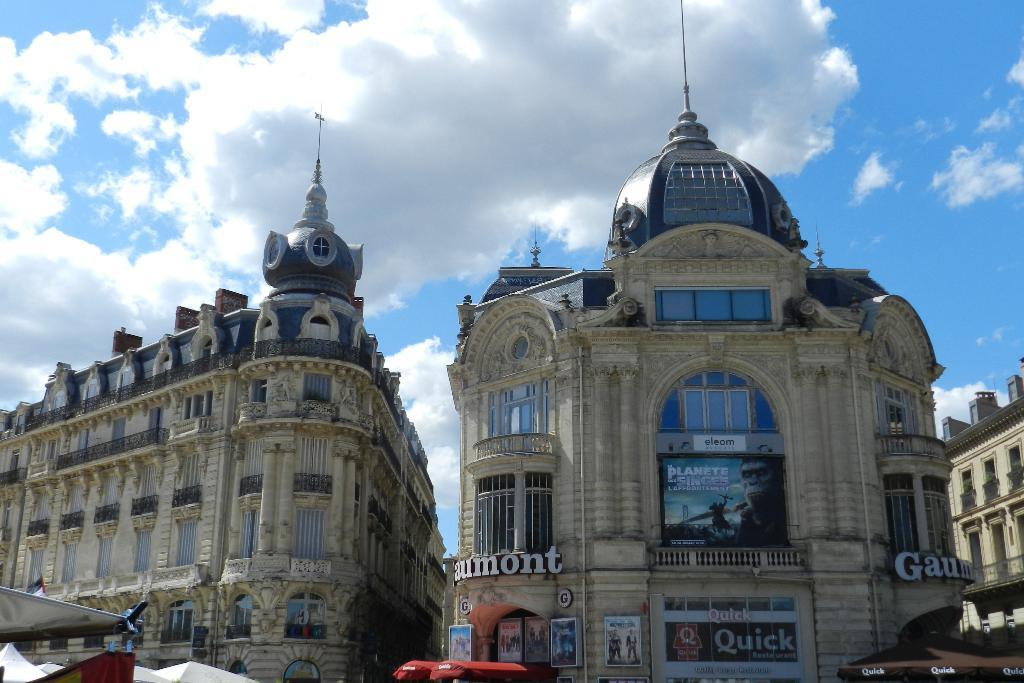What type of structures are depicted in the image? There are buildings with pillars and windows in the image. What additional elements can be seen in the image? There are banners in the image. What can be seen in the background of the image? The sky with clouds is visible in the background of the image. What is located at the bottom of the image? There are objects at the bottom of the image. What religious symbols are present in the image? There is no mention of religious symbols in the provided facts, so we cannot determine their presence in the image. 